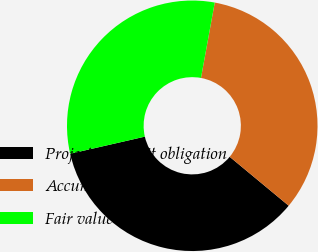Convert chart. <chart><loc_0><loc_0><loc_500><loc_500><pie_chart><fcel>Projected benefit obligation<fcel>Accumulated benefit obligation<fcel>Fair value of plan assets<nl><fcel>35.4%<fcel>33.14%<fcel>31.46%<nl></chart> 